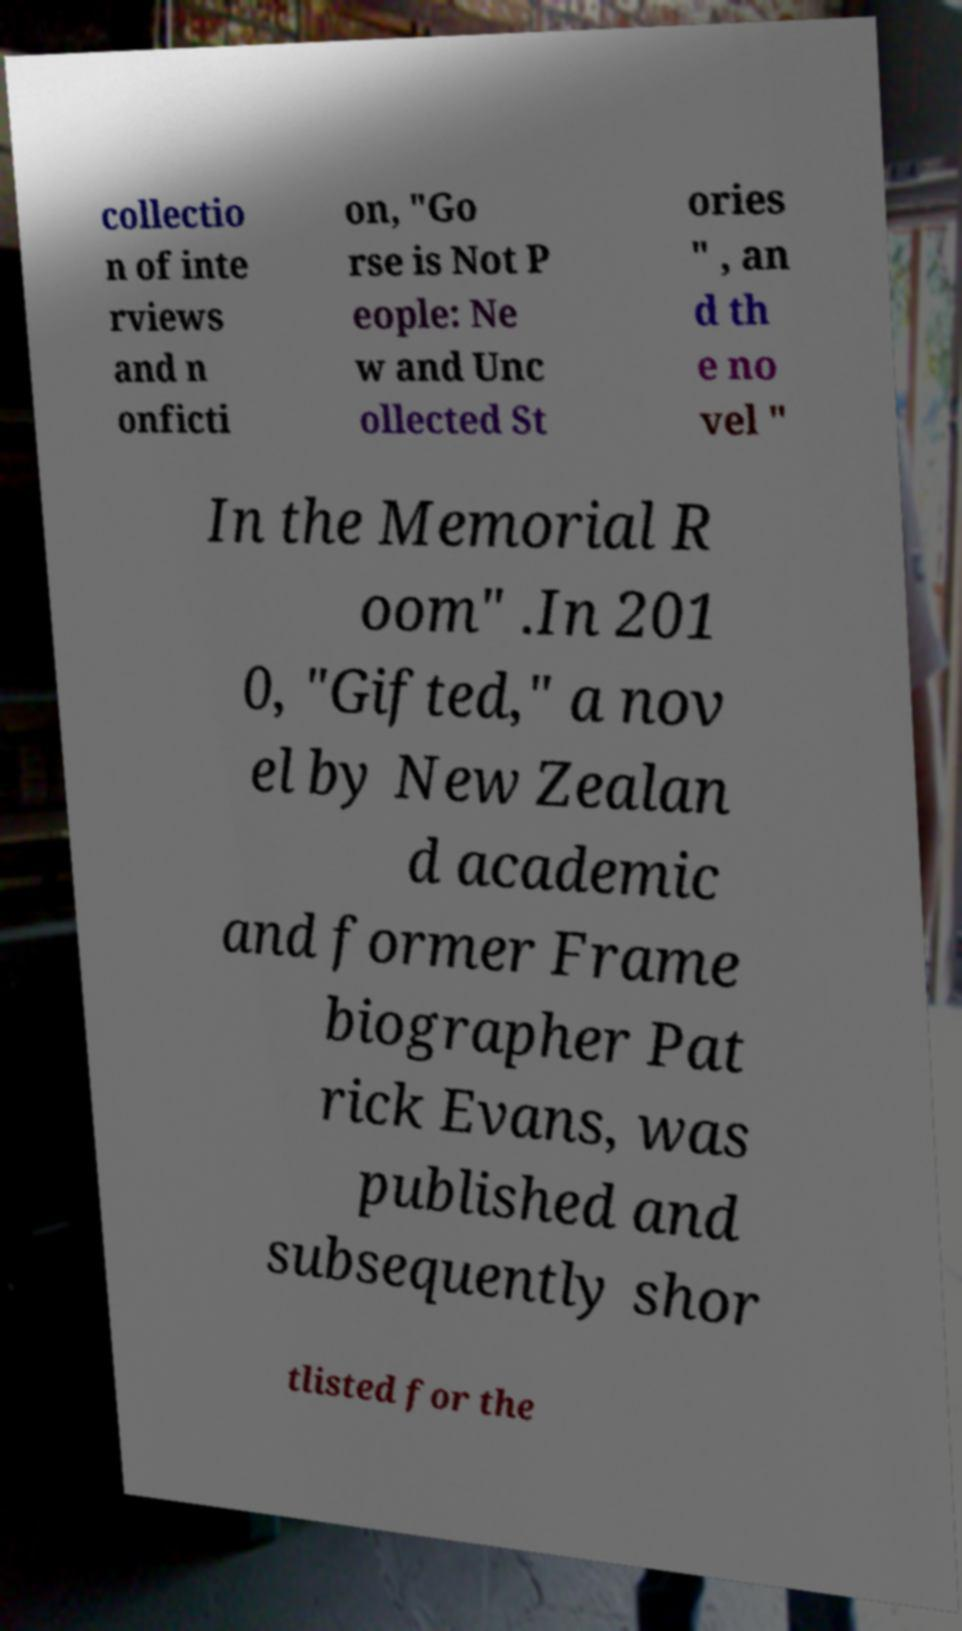Could you extract and type out the text from this image? collectio n of inte rviews and n onficti on, "Go rse is Not P eople: Ne w and Unc ollected St ories " , an d th e no vel " In the Memorial R oom" .In 201 0, "Gifted," a nov el by New Zealan d academic and former Frame biographer Pat rick Evans, was published and subsequently shor tlisted for the 